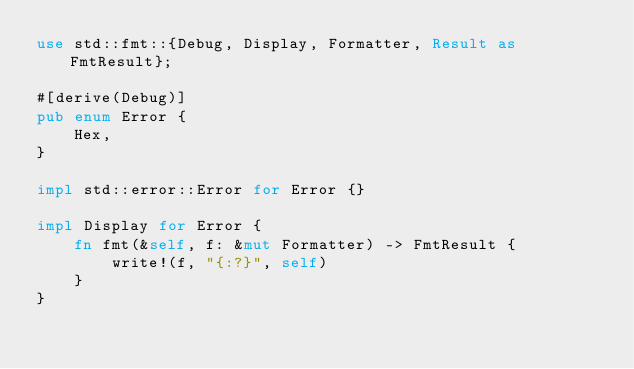<code> <loc_0><loc_0><loc_500><loc_500><_Rust_>use std::fmt::{Debug, Display, Formatter, Result as FmtResult};

#[derive(Debug)]
pub enum Error {
    Hex,
}

impl std::error::Error for Error {}

impl Display for Error {
    fn fmt(&self, f: &mut Formatter) -> FmtResult {
        write!(f, "{:?}", self)
    }
}
</code> 